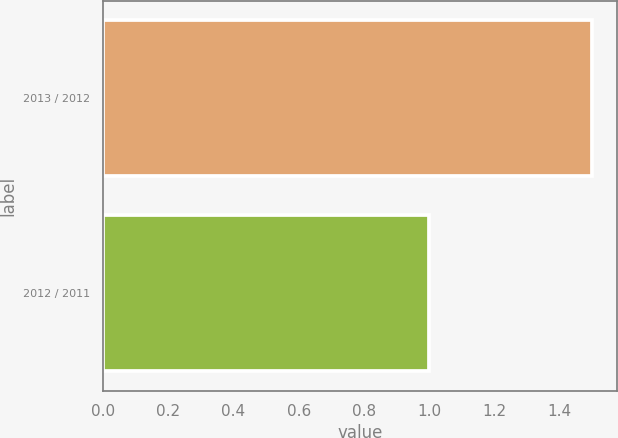Convert chart. <chart><loc_0><loc_0><loc_500><loc_500><bar_chart><fcel>2013 / 2012<fcel>2012 / 2011<nl><fcel>1.5<fcel>1<nl></chart> 